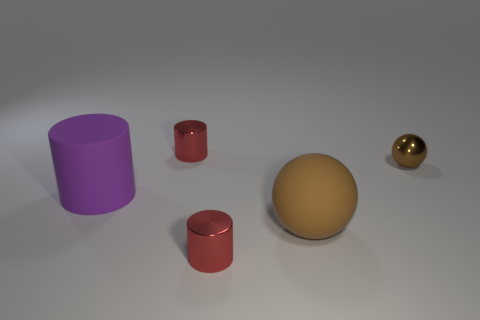Add 4 red cylinders. How many objects exist? 9 Subtract all small red cylinders. How many cylinders are left? 1 Subtract 1 balls. How many balls are left? 1 Subtract all tiny shiny spheres. Subtract all small brown things. How many objects are left? 3 Add 1 big rubber objects. How many big rubber objects are left? 3 Add 5 large metallic things. How many large metallic things exist? 5 Subtract all purple cylinders. How many cylinders are left? 2 Subtract 0 red spheres. How many objects are left? 5 Subtract all spheres. How many objects are left? 3 Subtract all gray spheres. Subtract all brown cylinders. How many spheres are left? 2 